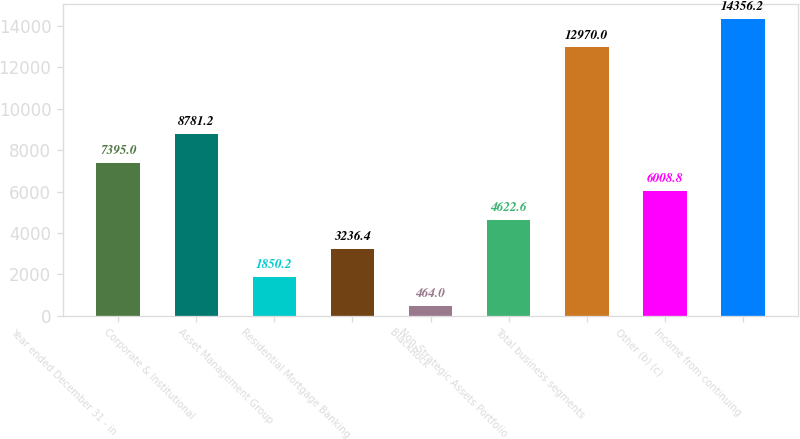<chart> <loc_0><loc_0><loc_500><loc_500><bar_chart><fcel>Year ended December 31 - in<fcel>Corporate & Institutional<fcel>Asset Management Group<fcel>Residential Mortgage Banking<fcel>BlackRock<fcel>Non-Strategic Assets Portfolio<fcel>Total business segments<fcel>Other (b) (c)<fcel>Income from continuing<nl><fcel>7395<fcel>8781.2<fcel>1850.2<fcel>3236.4<fcel>464<fcel>4622.6<fcel>12970<fcel>6008.8<fcel>14356.2<nl></chart> 